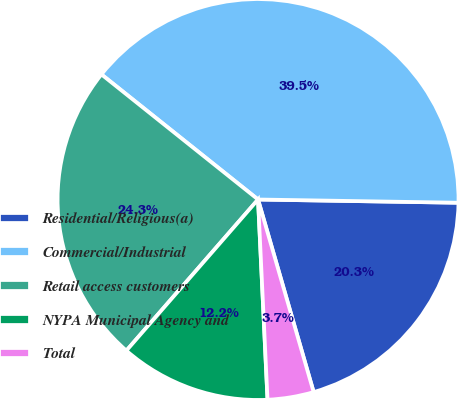<chart> <loc_0><loc_0><loc_500><loc_500><pie_chart><fcel>Residential/Religious(a)<fcel>Commercial/Industrial<fcel>Retail access customers<fcel>NYPA Municipal Agency and<fcel>Total<nl><fcel>20.27%<fcel>39.53%<fcel>24.32%<fcel>12.16%<fcel>3.72%<nl></chart> 